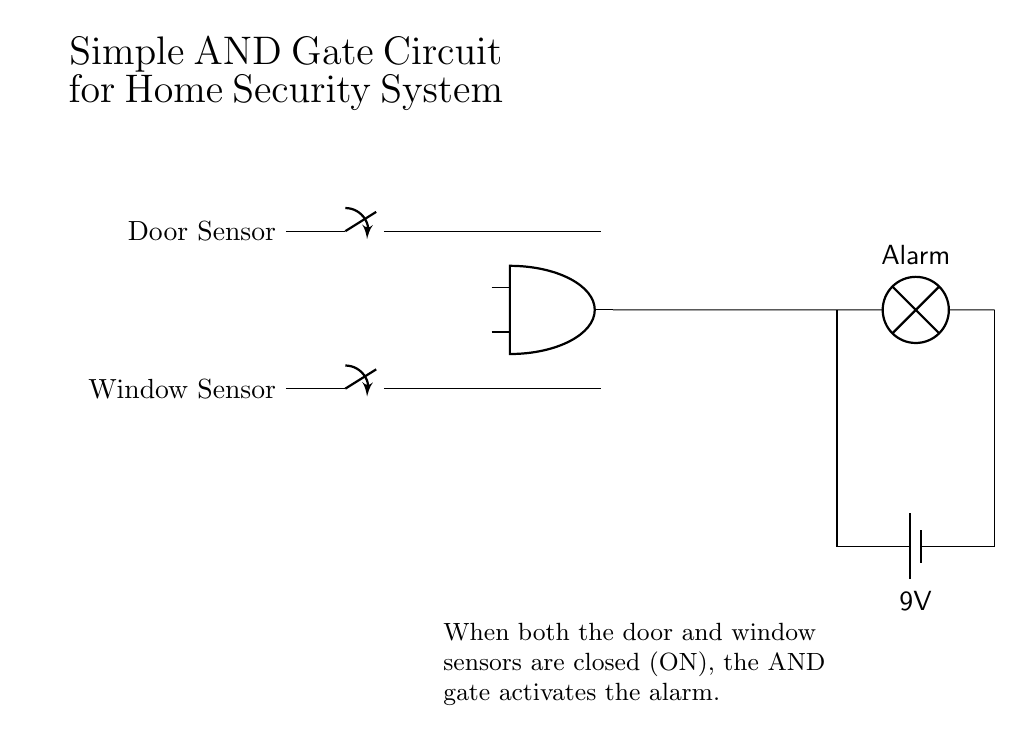What is the input device for the door sensor? The circuit shows a switch connected to represent the door sensor, indicating that it's a normally open switch which will close when the door is closed.
Answer: switch What does the AND gate output when both inputs are ON? The AND gate outputs a signal that activates the alarm when both switches (door sensor and window sensor) are closed (ON), confirming that all conditions are met for alarm activation.
Answer: Alarm How many sensors are connected to the AND gate? The circuit features two sensors: one for the door and one for the window, both of which are inputs to the AND gate.
Answer: two What is the type of battery used in this circuit? The circuit diagram identifies the power supply used as a 9-volt battery, indicating the voltage level provided for the operation of the components.
Answer: 9V What happens if one of the sensors is open? If either the door or window switch is open (OFF), the input to the AND gate is not met, meaning the gate will not output a signal, and consequently, the alarm will not activate.
Answer: Alarm off What is the role of the AND gate in this circuit? The AND gate functions as a logical operator that requires both input conditions (door and window sensors) to be satisfied (both closed) to activate the alarm output, showcasing the logic of a security system setup.
Answer: logical operator 